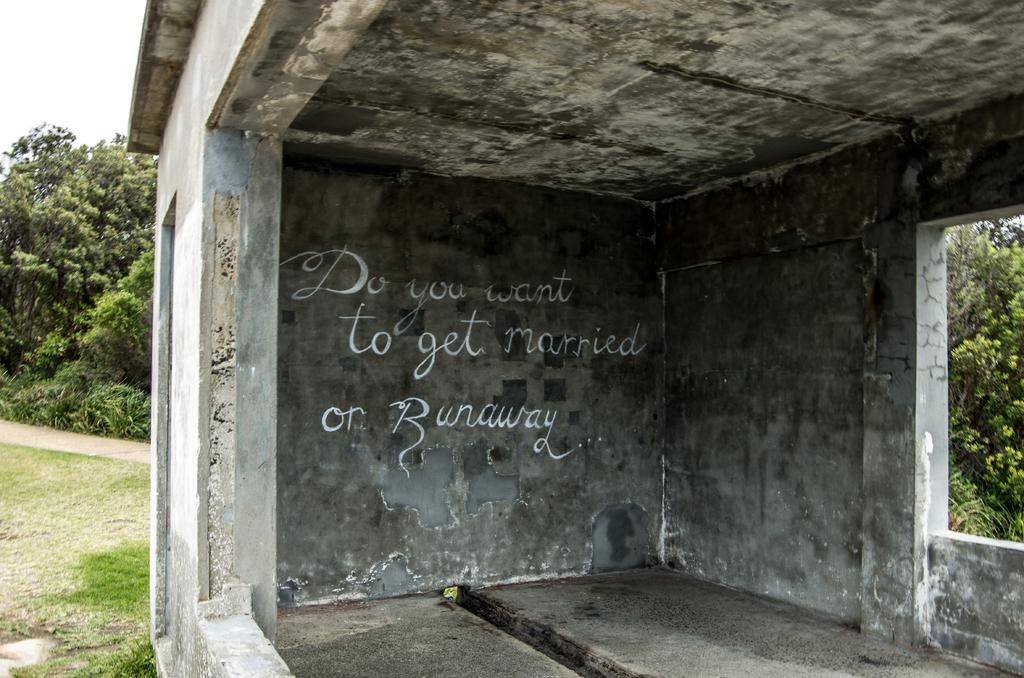In one or two sentences, can you explain what this image depicts? This is a picture of a building, where there are some words written on the wall, and in the background there are plants, grass, trees,sky. 